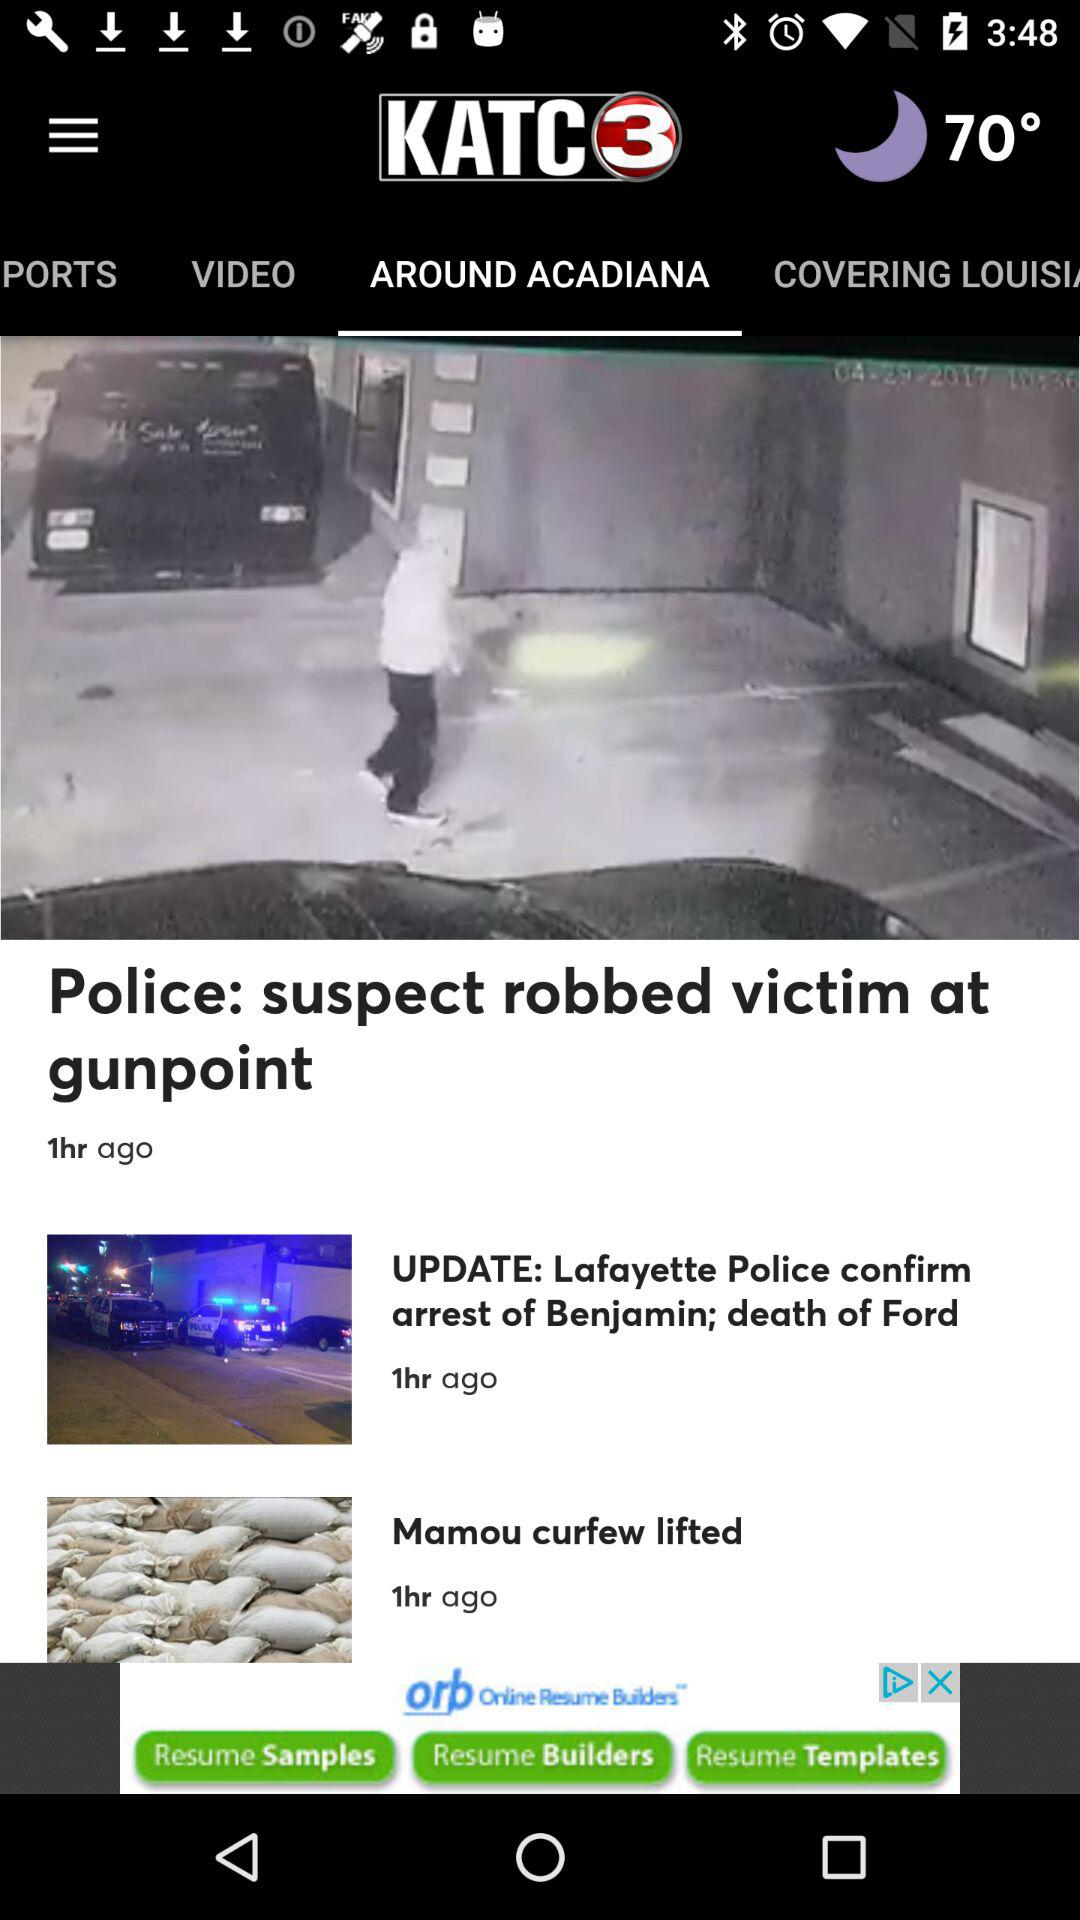What is the headline? The headline is "Police: suspect robbed victim at gunpoint". 